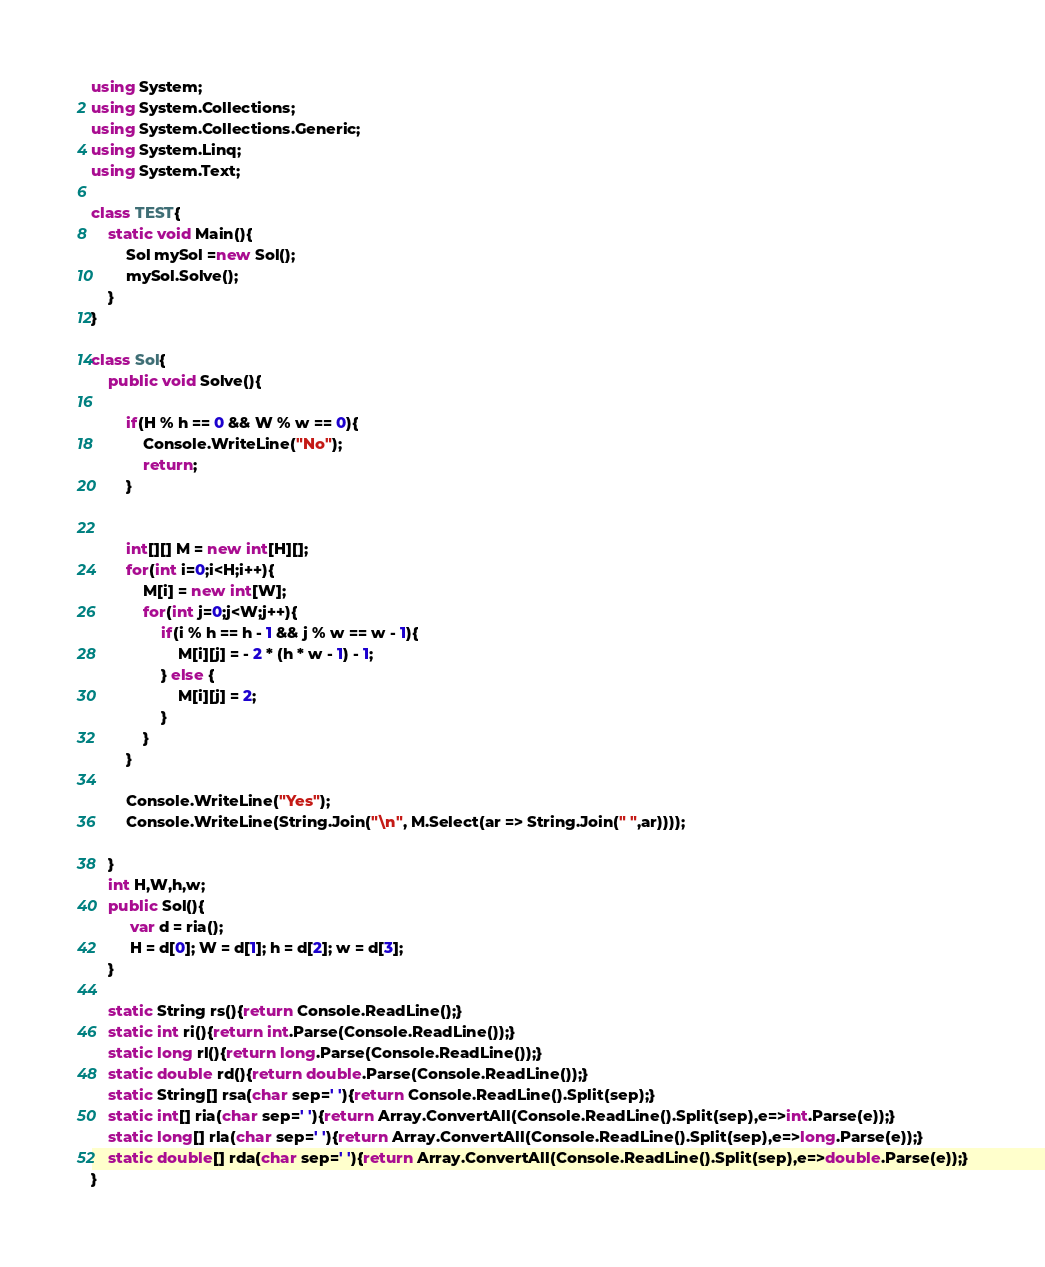Convert code to text. <code><loc_0><loc_0><loc_500><loc_500><_C#_>using System;
using System.Collections;
using System.Collections.Generic;
using System.Linq;
using System.Text;

class TEST{
	static void Main(){
		Sol mySol =new Sol();
		mySol.Solve();
	}
}

class Sol{
	public void Solve(){
		
		if(H % h == 0 && W % w == 0){
			Console.WriteLine("No");
			return;
		}
		
		
		int[][] M = new int[H][];
		for(int i=0;i<H;i++){
			M[i] = new int[W];
			for(int j=0;j<W;j++){
				if(i % h == h - 1 && j % w == w - 1){
					M[i][j] = - 2 * (h * w - 1) - 1;
				} else {
					M[i][j] = 2;
				}
			}
		}
		
		Console.WriteLine("Yes");
		Console.WriteLine(String.Join("\n", M.Select(ar => String.Join(" ",ar))));
		
	}
	int H,W,h,w;
	public Sol(){
		 var d = ria();
		 H = d[0]; W = d[1]; h = d[2]; w = d[3];
	}

	static String rs(){return Console.ReadLine();}
	static int ri(){return int.Parse(Console.ReadLine());}
	static long rl(){return long.Parse(Console.ReadLine());}
	static double rd(){return double.Parse(Console.ReadLine());}
	static String[] rsa(char sep=' '){return Console.ReadLine().Split(sep);}
	static int[] ria(char sep=' '){return Array.ConvertAll(Console.ReadLine().Split(sep),e=>int.Parse(e));}
	static long[] rla(char sep=' '){return Array.ConvertAll(Console.ReadLine().Split(sep),e=>long.Parse(e));}
	static double[] rda(char sep=' '){return Array.ConvertAll(Console.ReadLine().Split(sep),e=>double.Parse(e));}
}
</code> 